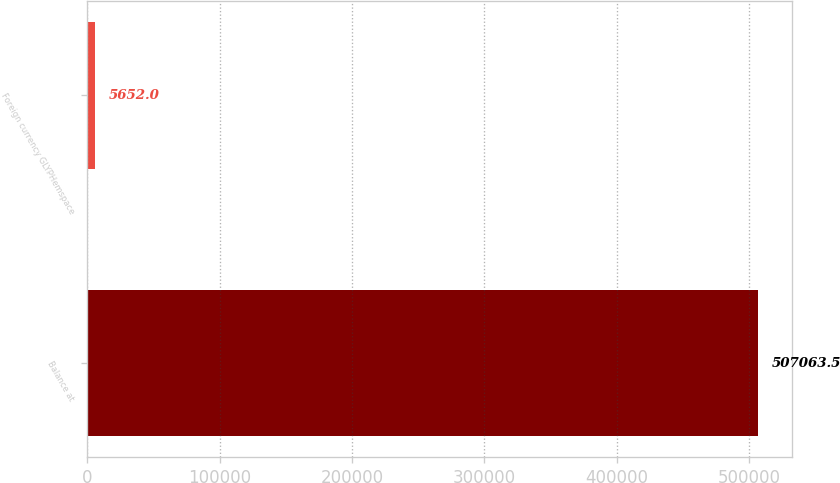<chart> <loc_0><loc_0><loc_500><loc_500><bar_chart><fcel>Balance at<fcel>Foreign currency GLYPHemspace<nl><fcel>507064<fcel>5652<nl></chart> 